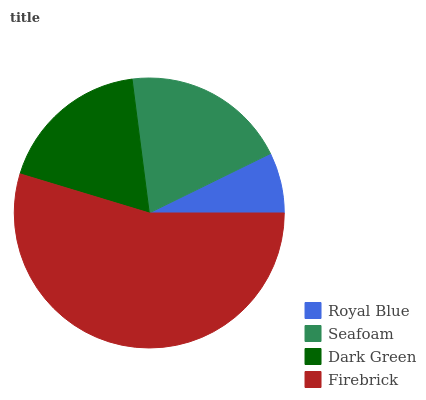Is Royal Blue the minimum?
Answer yes or no. Yes. Is Firebrick the maximum?
Answer yes or no. Yes. Is Seafoam the minimum?
Answer yes or no. No. Is Seafoam the maximum?
Answer yes or no. No. Is Seafoam greater than Royal Blue?
Answer yes or no. Yes. Is Royal Blue less than Seafoam?
Answer yes or no. Yes. Is Royal Blue greater than Seafoam?
Answer yes or no. No. Is Seafoam less than Royal Blue?
Answer yes or no. No. Is Seafoam the high median?
Answer yes or no. Yes. Is Dark Green the low median?
Answer yes or no. Yes. Is Royal Blue the high median?
Answer yes or no. No. Is Royal Blue the low median?
Answer yes or no. No. 